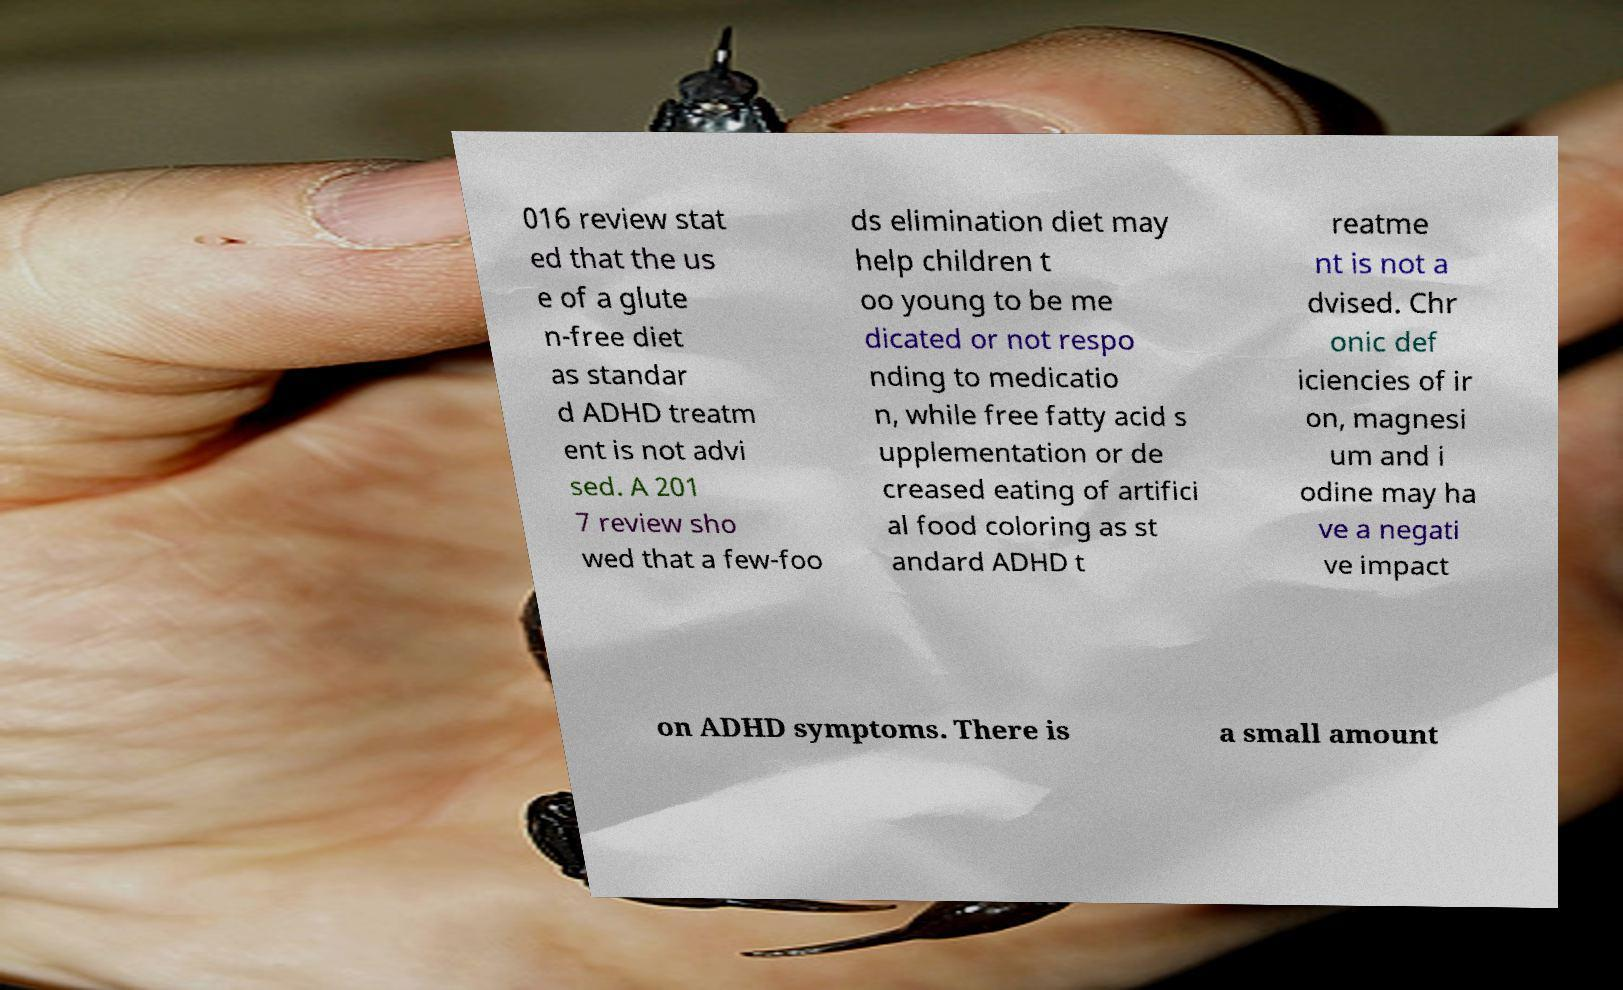Could you assist in decoding the text presented in this image and type it out clearly? 016 review stat ed that the us e of a glute n-free diet as standar d ADHD treatm ent is not advi sed. A 201 7 review sho wed that a few-foo ds elimination diet may help children t oo young to be me dicated or not respo nding to medicatio n, while free fatty acid s upplementation or de creased eating of artifici al food coloring as st andard ADHD t reatme nt is not a dvised. Chr onic def iciencies of ir on, magnesi um and i odine may ha ve a negati ve impact on ADHD symptoms. There is a small amount 